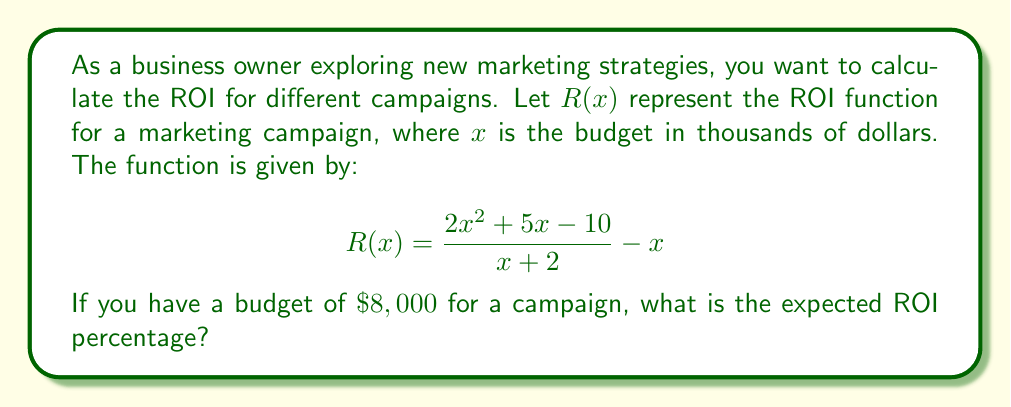Provide a solution to this math problem. To solve this problem, we'll follow these steps:

1. Identify the given information:
   - ROI function: $R(x) = \frac{2x^2 + 5x - 10}{x + 2} - x$
   - Budget: $\$8,000 = 8$ (since $x$ is in thousands of dollars)

2. Substitute $x = 8$ into the function:
   $$R(8) = \frac{2(8)^2 + 5(8) - 10}{8 + 2} - 8$$

3. Simplify the numerator:
   $$R(8) = \frac{2(64) + 40 - 10}{10} - 8 = \frac{128 + 40 - 10}{10} - 8 = \frac{158}{10} - 8$$

4. Perform the division:
   $$R(8) = 15.8 - 8 = 7.8$$

5. Convert the result to a percentage:
   ROI percentage = $7.8 \times 100\% = 780\%$

Therefore, with a budget of $\$8,000$, the expected ROI is 780%.
Answer: 780% 